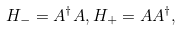<formula> <loc_0><loc_0><loc_500><loc_500>H _ { - } = A ^ { \dagger } A , H _ { + } = A A ^ { \dagger } ,</formula> 